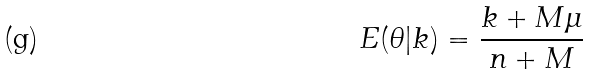<formula> <loc_0><loc_0><loc_500><loc_500>E ( \theta | k ) = \frac { k + M \mu } { n + M }</formula> 